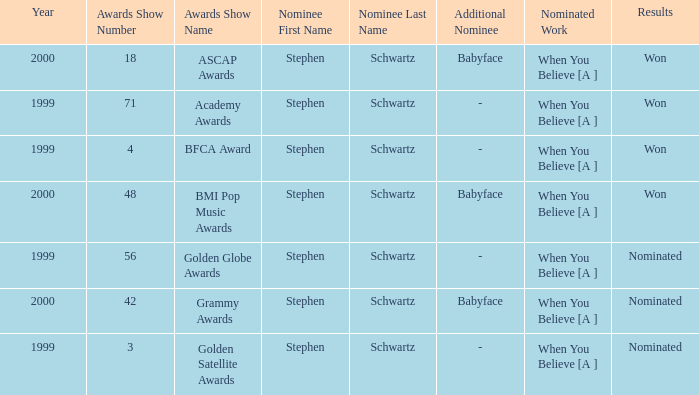Which Nominated Work won in 2000? When You Believe [A ], When You Believe [A ]. Give me the full table as a dictionary. {'header': ['Year', 'Awards Show Number', 'Awards Show Name', 'Nominee First Name', 'Nominee Last Name', 'Additional Nominee', 'Nominated Work', 'Results'], 'rows': [['2000', '18', 'ASCAP Awards', 'Stephen', 'Schwartz', 'Babyface', 'When You Believe [A ]', 'Won'], ['1999', '71', 'Academy Awards', 'Stephen', 'Schwartz', '-', 'When You Believe [A ]', 'Won'], ['1999', '4', 'BFCA Award', 'Stephen', 'Schwartz', '-', 'When You Believe [A ]', 'Won'], ['2000', '48', 'BMI Pop Music Awards', 'Stephen', 'Schwartz', 'Babyface', 'When You Believe [A ]', 'Won'], ['1999', '56', 'Golden Globe Awards', 'Stephen', 'Schwartz', '-', 'When You Believe [A ]', 'Nominated'], ['2000', '42', 'Grammy Awards', 'Stephen', 'Schwartz', 'Babyface', 'When You Believe [A ]', 'Nominated'], ['1999', '3', 'Golden Satellite Awards', 'Stephen', 'Schwartz', '-', 'When You Believe [A ]', 'Nominated']]} 